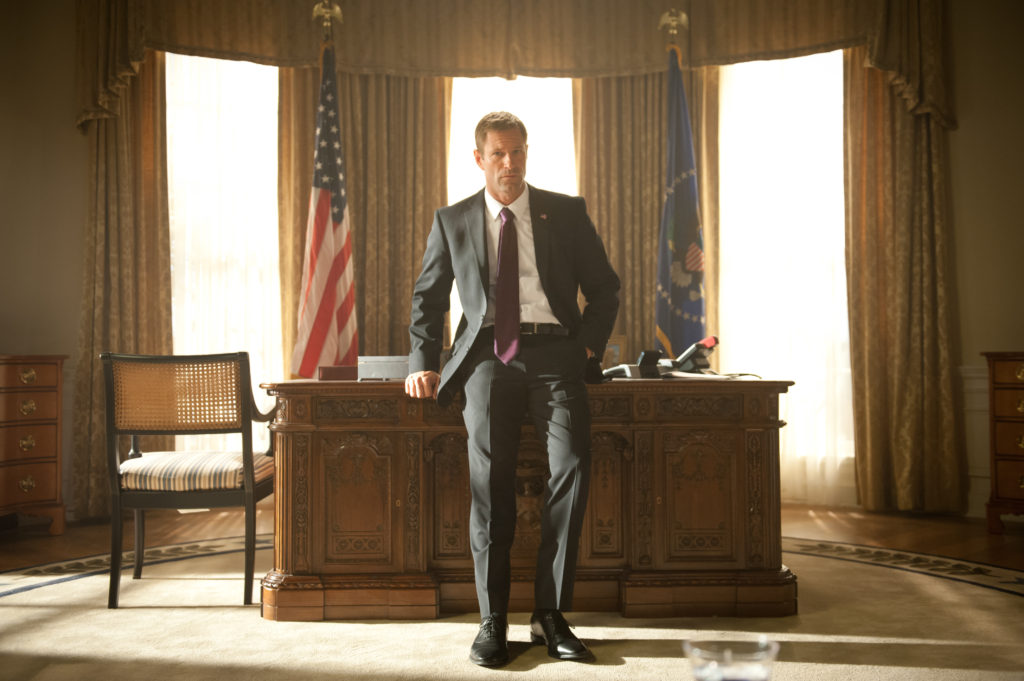Describe the setting in which the character is positioned. The character stands in a grand room that closely resembles the Oval Office. The room has an elegant and formal feel, characterized by tall, curtained windows casting natural light onto the scene. The centerpiece of the room is an elaborate wooden desk with intricate carvings, reflecting the importance and gravitas of the setting. Behind the character, two flags – the American flag and a blue flag with a golden eagle – add to the presidential aura. The overall ambiance is one of authority, sophistication, and historical significance, with every element meticulously chosen to reinforce the theme of leadership and power. 